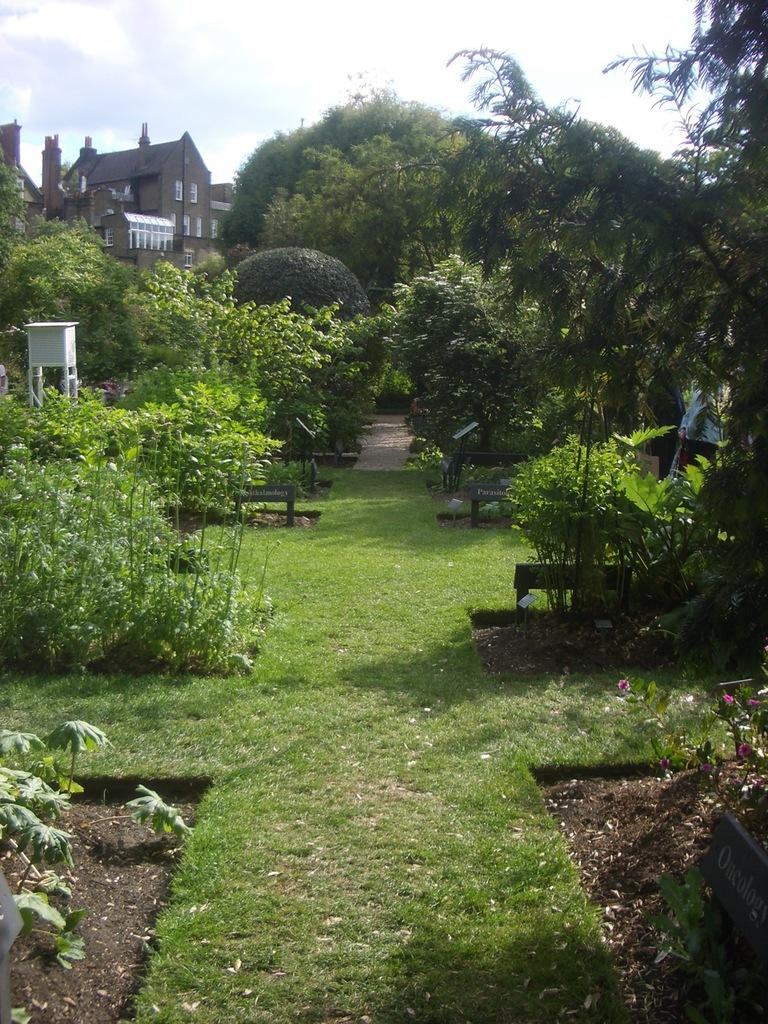What type of vegetation can be seen in the image? There is grass in the image. What other natural elements are present in the image? There are trees in the image. Are there any man-made structures visible in the image? Yes, there is a castle in the image. What is the condition of the sky in the image? The sky is visible in the image, and there are clouds present. What might people use to sit and rest in the image? There are benches in the image. What type of riddle can be solved by looking at the grass in the image? There is no riddle present in the image, and the grass does not contain any information that would help solve a riddle. 